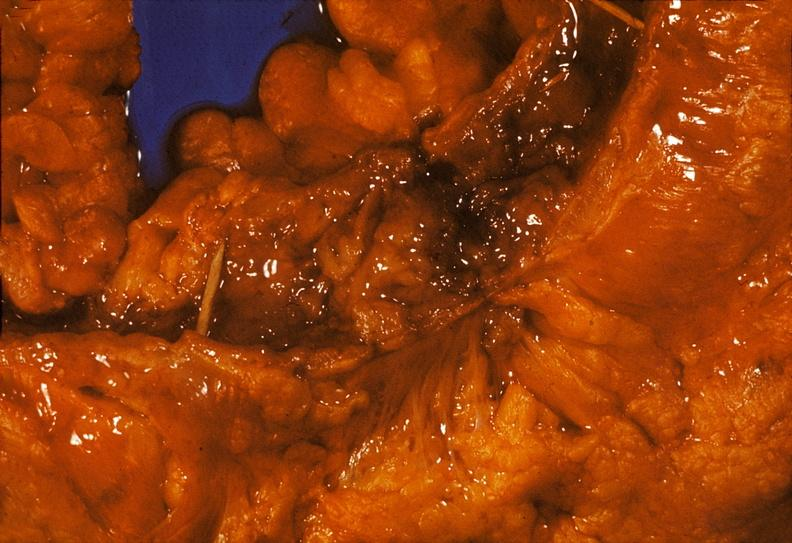does autopsy show colon, chronic ulcerative colitis, pseudopolyps?
Answer the question using a single word or phrase. No 